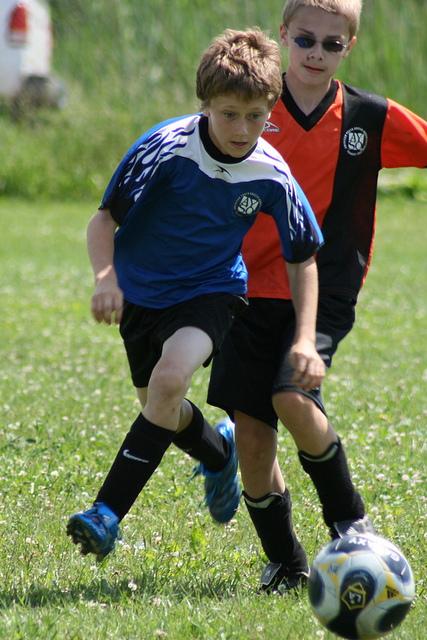What are these boys playing?
Write a very short answer. Soccer. Which sport is this?
Write a very short answer. Soccer. What type of shoes are the boys wearing?
Answer briefly. Cleats. 